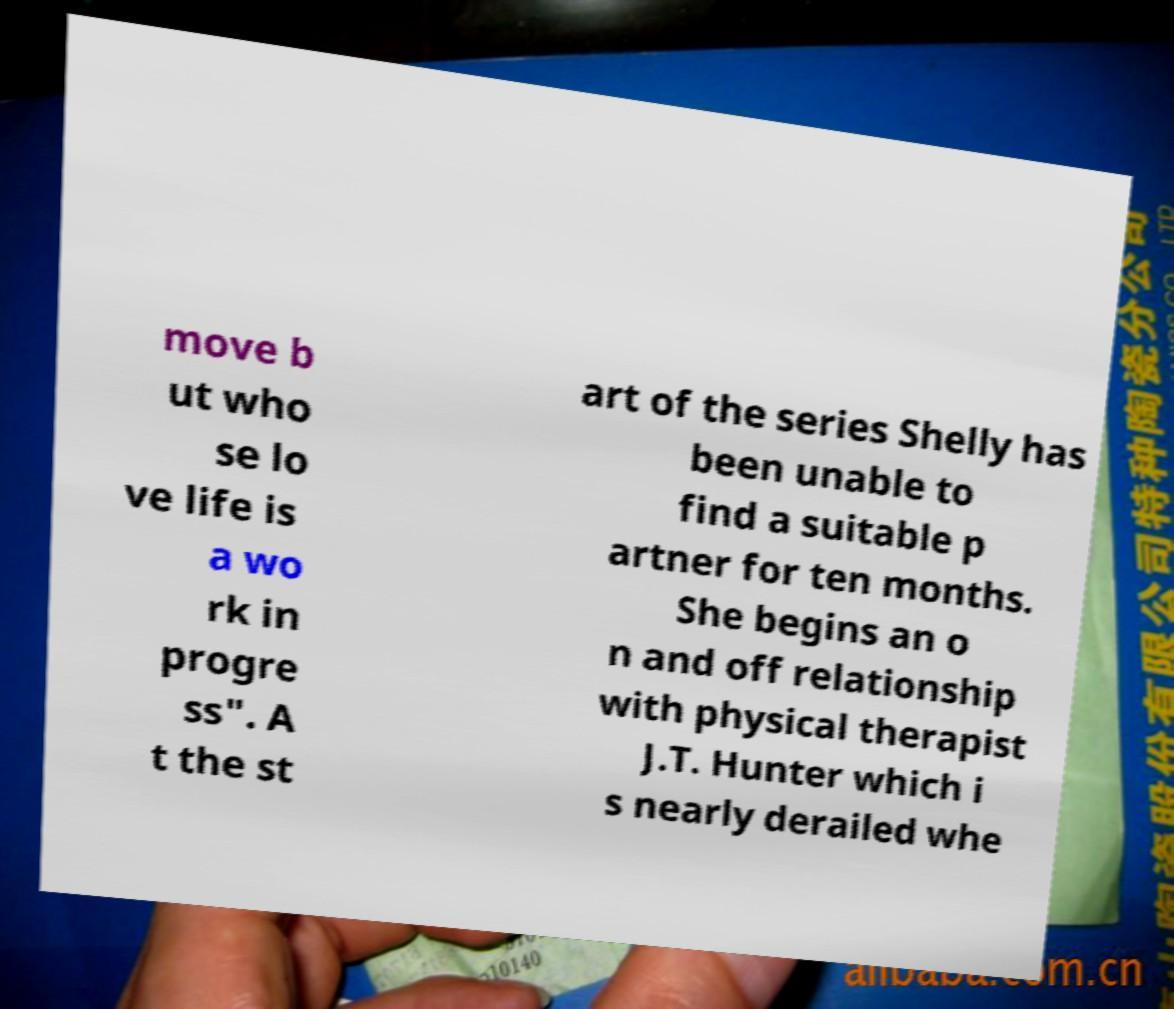Please identify and transcribe the text found in this image. move b ut who se lo ve life is a wo rk in progre ss". A t the st art of the series Shelly has been unable to find a suitable p artner for ten months. She begins an o n and off relationship with physical therapist J.T. Hunter which i s nearly derailed whe 